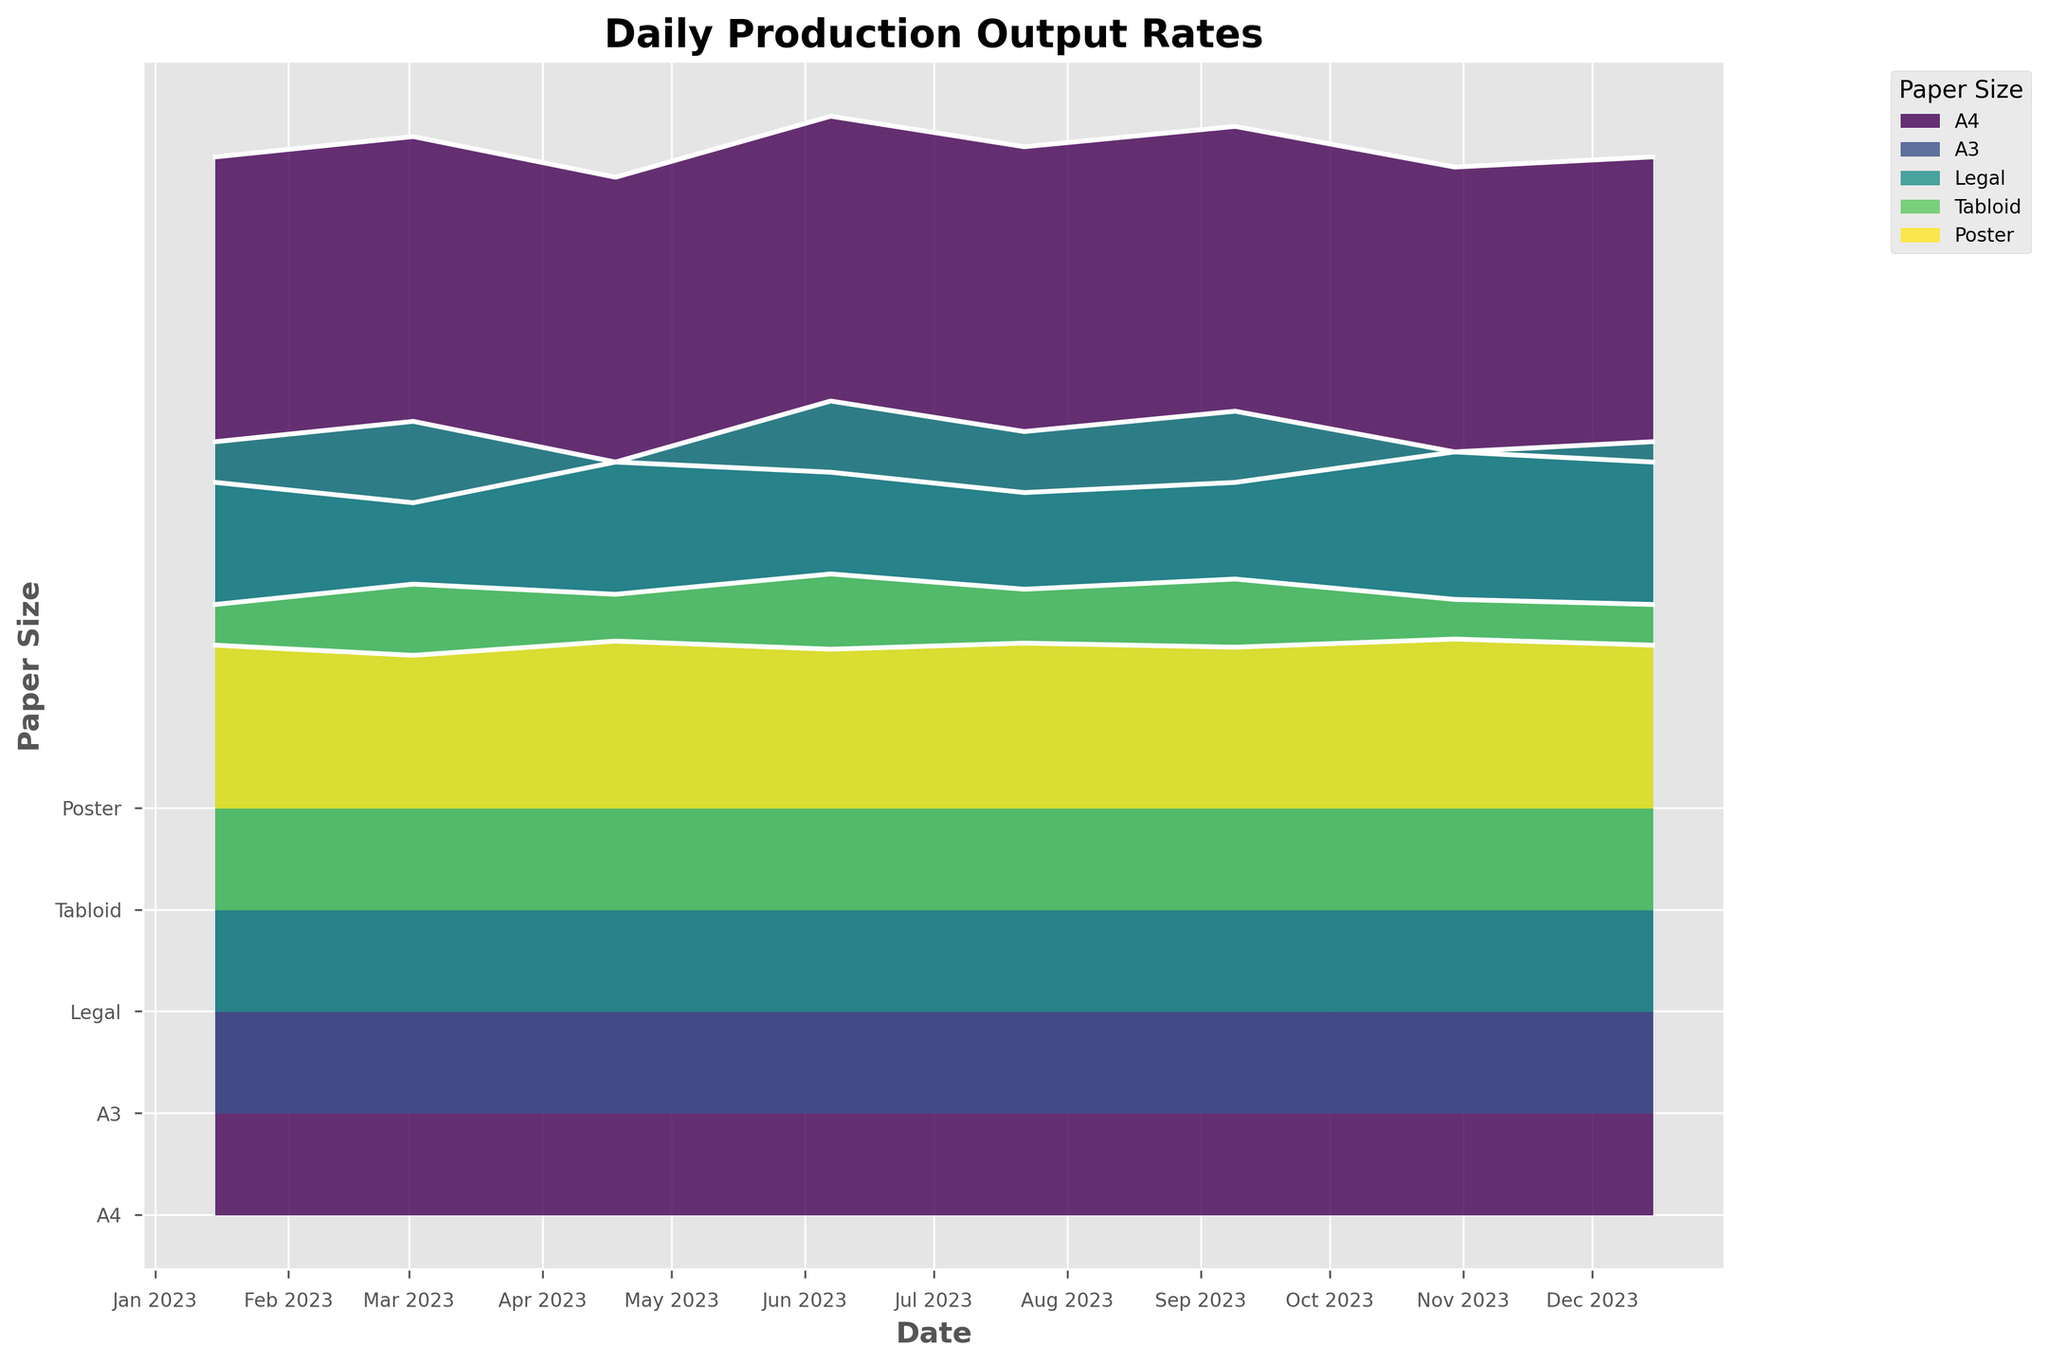How many different paper sizes are represented in the plot? The plot shows distinct layers for each paper size, each with a legend, and you can count them.
Answer: 5 What is the title of the plot? The title is located at the top of the plot, clearly stating the purpose of the visualization.
Answer: Daily Production Output Rates Which month shows the highest production rate for A4 paper? Look at the peaks of the A4 layer along the x-axis representing dates. Identify the highest peak.
Answer: June What is the average production rate for Tabloid paper in the months provided? Sum the production rates for Tabloid paper and divide by the number of months. \( (1500 + 1600 + 1550 + 1650 + 1575 + 1625 + 1525 + 1500) / 8 = 15025 / 8 \)
Answer: 1878.125 How does the production of Poster compare to Legal in August? Check the midyear value for both Poster and Legal paper sizes. Estimate their values and compare.
Answer: Legal is higher In which month is the Poster paper production the lowest? Identify which month has the lowest peak value for Poster paper size along the x-axis.
Answer: March Which paper size has the most consistent production rate throughout the year? Assess the smoothness and uniformity of each paper size layer, looking for the least variation.
Answer: Poster What is the relative increase in production from April to June for A3 paper? Subtract the April value for A3 from the June value, then divide by the April value and multiply by 100 to get the percentage increase. \( (3150 - 3200) / 3200 \times 100 = -1.56% \)
Answer: -1.56% Which paper size peaks in December, and how does it compare to its lowest production value? Identify the peak in December for each layer, find its highest, then see how it stands against the same series' lowest point.
Answer: A4; The highest is 5200, and it is equal to its lowest point in January, which is also 5200 